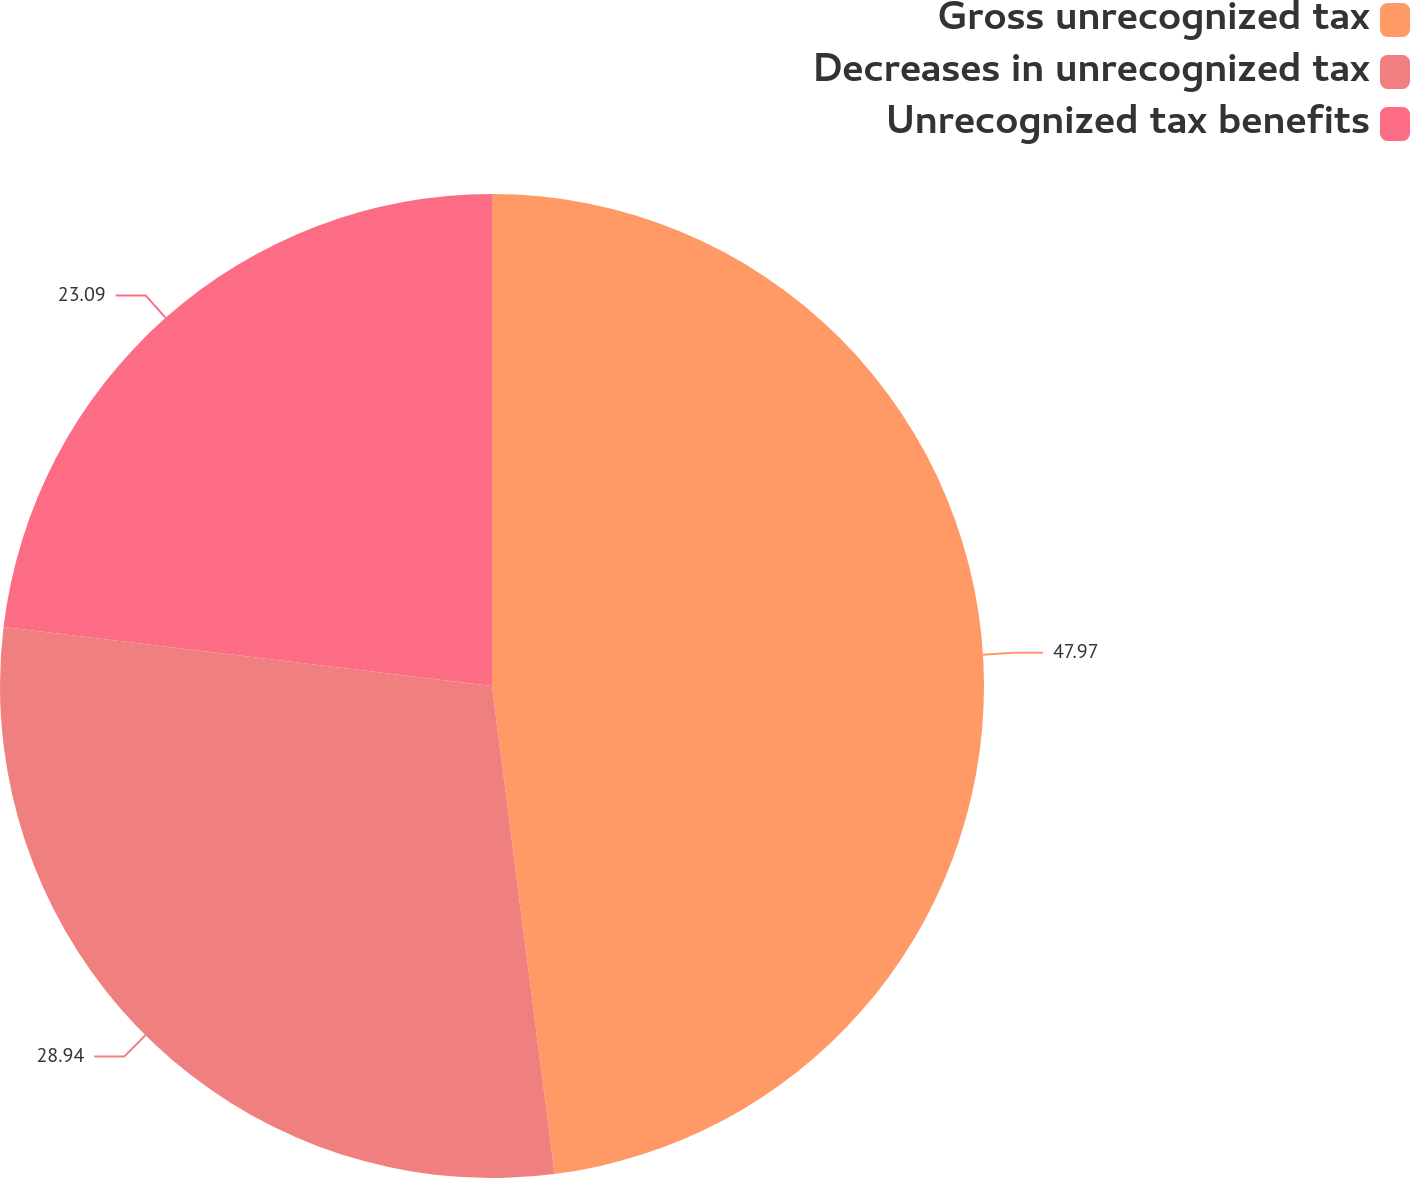<chart> <loc_0><loc_0><loc_500><loc_500><pie_chart><fcel>Gross unrecognized tax<fcel>Decreases in unrecognized tax<fcel>Unrecognized tax benefits<nl><fcel>47.97%<fcel>28.94%<fcel>23.09%<nl></chart> 